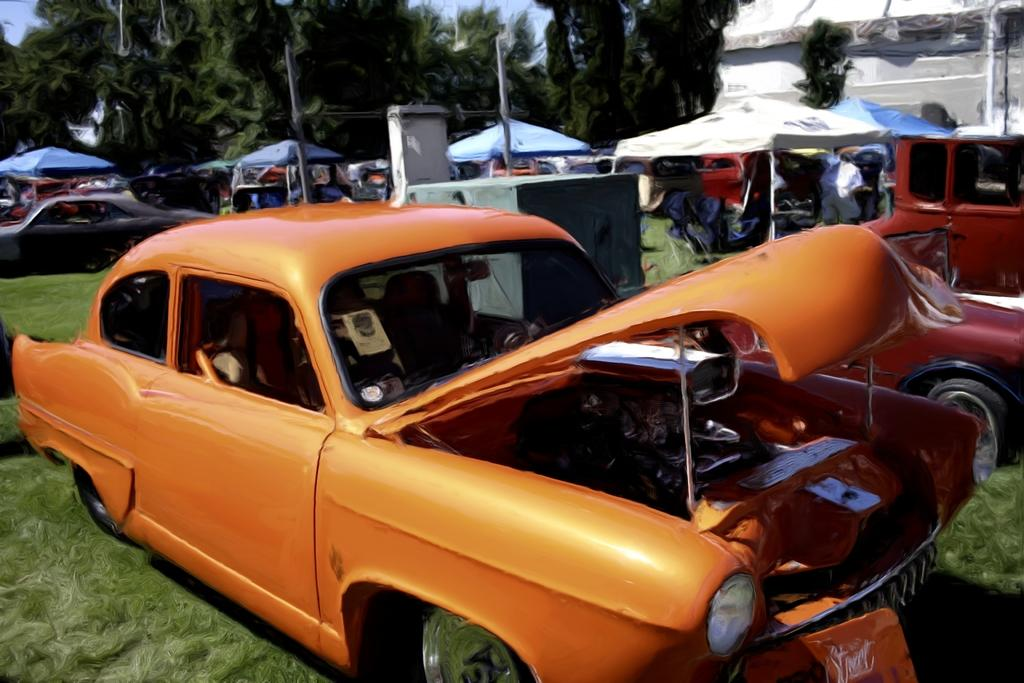What types of objects are present in the image? There are vehicles in the image. Can you describe one of the vehicles? One of the vehicles is orange. What can be seen in the background of the image? There are white tents, green trees, and a blue sky in the background. What type of prose can be heard being read from the swing in the image? There is no swing or prose present in the image. What type of clouds can be seen in the image? There are no clouds visible in the image; the sky is blue. 